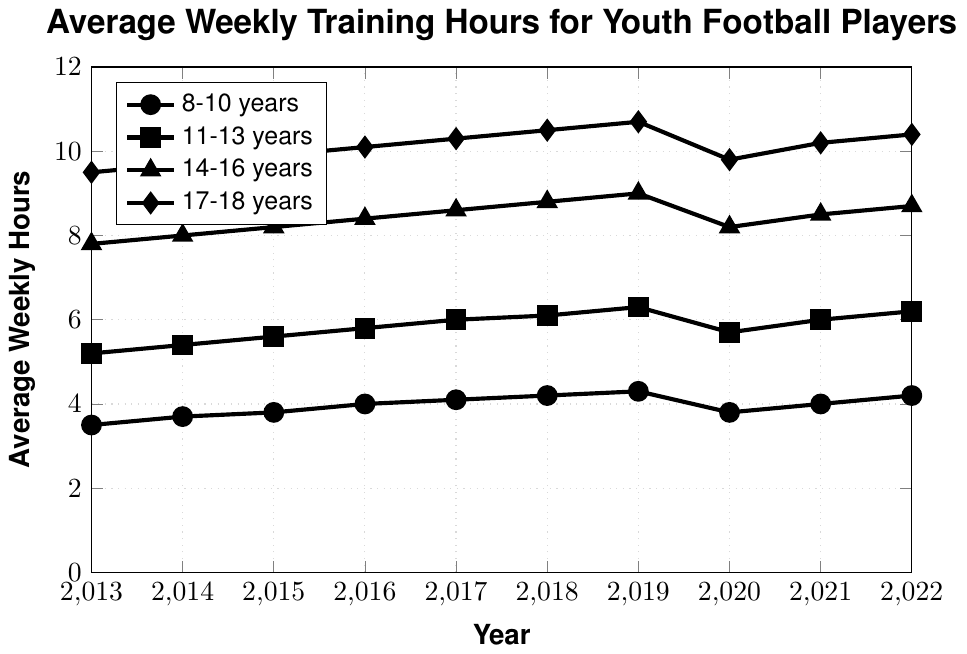What was the average weekly training hours for 14-16 years old players in 2017? To find the answer, locate the 14-16 years age group and the year 2017 in the chart. The corresponding value is the average weekly training hours for that year and age group.
Answer: 8.6 By how much did the average weekly training hours for 17-18 years old players change from 2013 to 2022? Identify the values for the 17-18 years age group in 2013 and 2022. Subtract the value for 2013 from the value for 2022: 10.4 - 9.5.
Answer: 0.9 Which age group had the highest average weekly training hours in 2019? Look at the year 2019 across all age groups. The 17-18 years age group has the highest value for that year.
Answer: 17-18 years What was the difference in average weekly training hours between the 8-10 years and 11-13 years age groups in 2020? Find the values for both age groups in 2020 and subtract the value for the 8-10 years group from the 11-13 years group: 5.7 - 3.8.
Answer: 1.9 What is the general trend in average weekly training hours for the 8-10 years age group from 2013 to 2022? Observe the line representing the 8-10 years age group across the years 2013 to 2022. There is an overall increasing trend with a slight dip in 2020.
Answer: Increasing trend How does the average weekly training hours for 11-13 years old players in 2014 compare to the value in 2022? Locate the values for the 11-13 years age group in 2014 and 2022. Compare the two values: 5.4 and 6.2, respectively.
Answer: Higher in 2022 Which age group had the smallest change in average weekly training hours during the pandemic year 2020 compared to the previous year? Compare the values for each age group in 2019 and 2020, and find the group with the smallest difference. The 17-18 years group had the smallest change: 9.8 - 10.7 = -0.9.
Answer: 17-18 years What was the average weekly training hours for the 14-16 years age group in 2018? Locate the 14-16 years age group and the year 2018 on the chart. The corresponding value is the average weekly training hours for that year and age group.
Answer: 8.8 